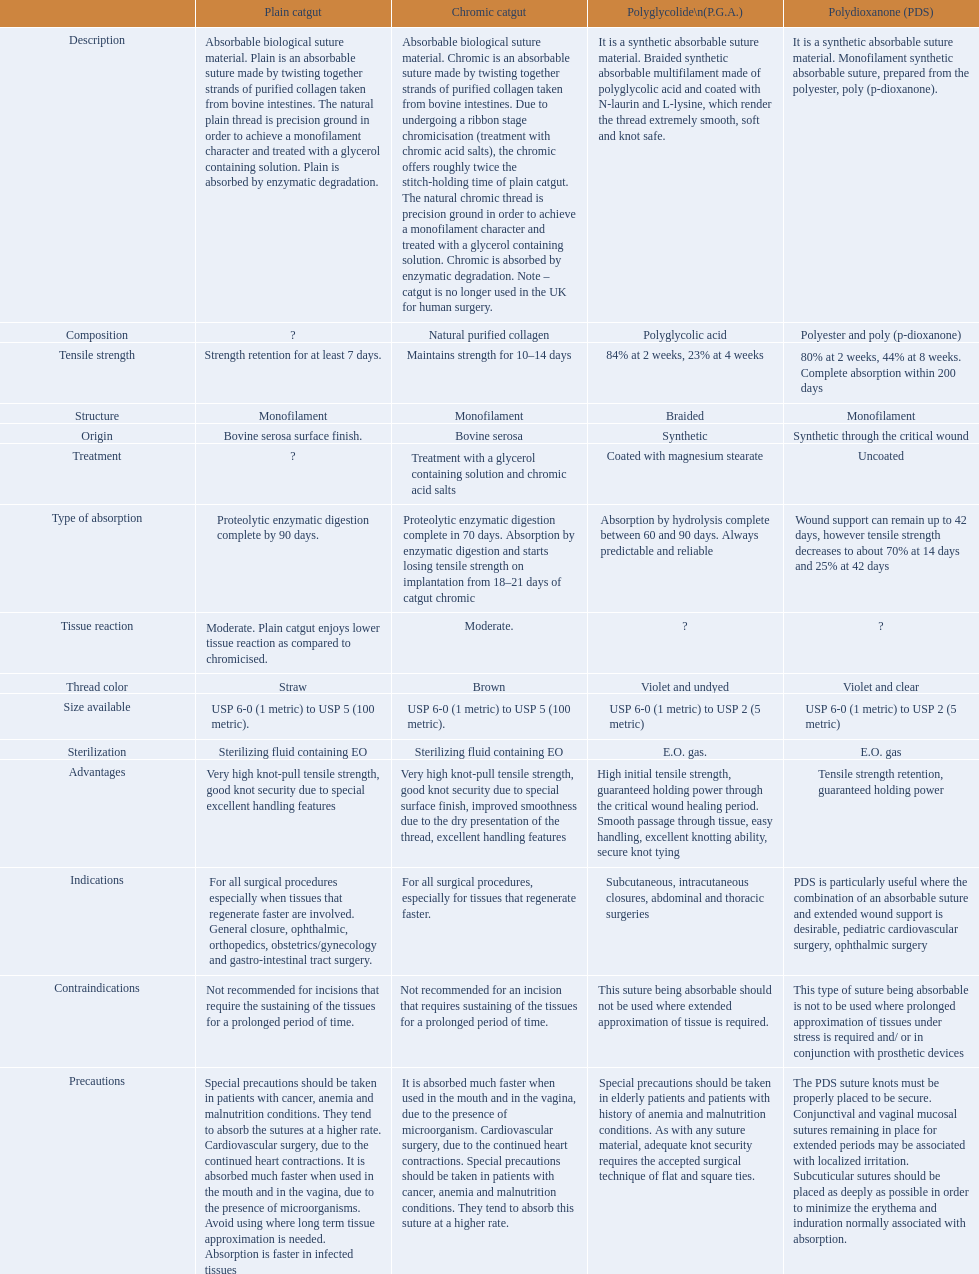In the suture materials comparison chart, what categories can be found? Description, Composition, Tensile strength, Structure, Origin, Treatment, Type of absorption, Tissue reaction, Thread color, Size available, Sterilization, Advantages, Indications, Contraindications, Precautions. Which textile strength has the minimum score? Strength retention for at least 7 days. 